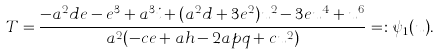<formula> <loc_0><loc_0><loc_500><loc_500>T = \frac { - a ^ { 2 } d e - e ^ { 3 } + a ^ { 3 } i + ( a ^ { 2 } d + 3 e ^ { 2 } ) u ^ { 2 } - 3 e u ^ { 4 } + u ^ { 6 } } { a ^ { 2 } ( - c e + a h - 2 a p q + c u ^ { 2 } ) } = \colon \psi _ { 1 } ( u ) .</formula> 